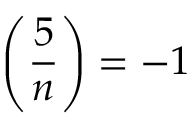Convert formula to latex. <formula><loc_0><loc_0><loc_500><loc_500>\left ( { \frac { 5 } { n } } \right ) = - 1</formula> 